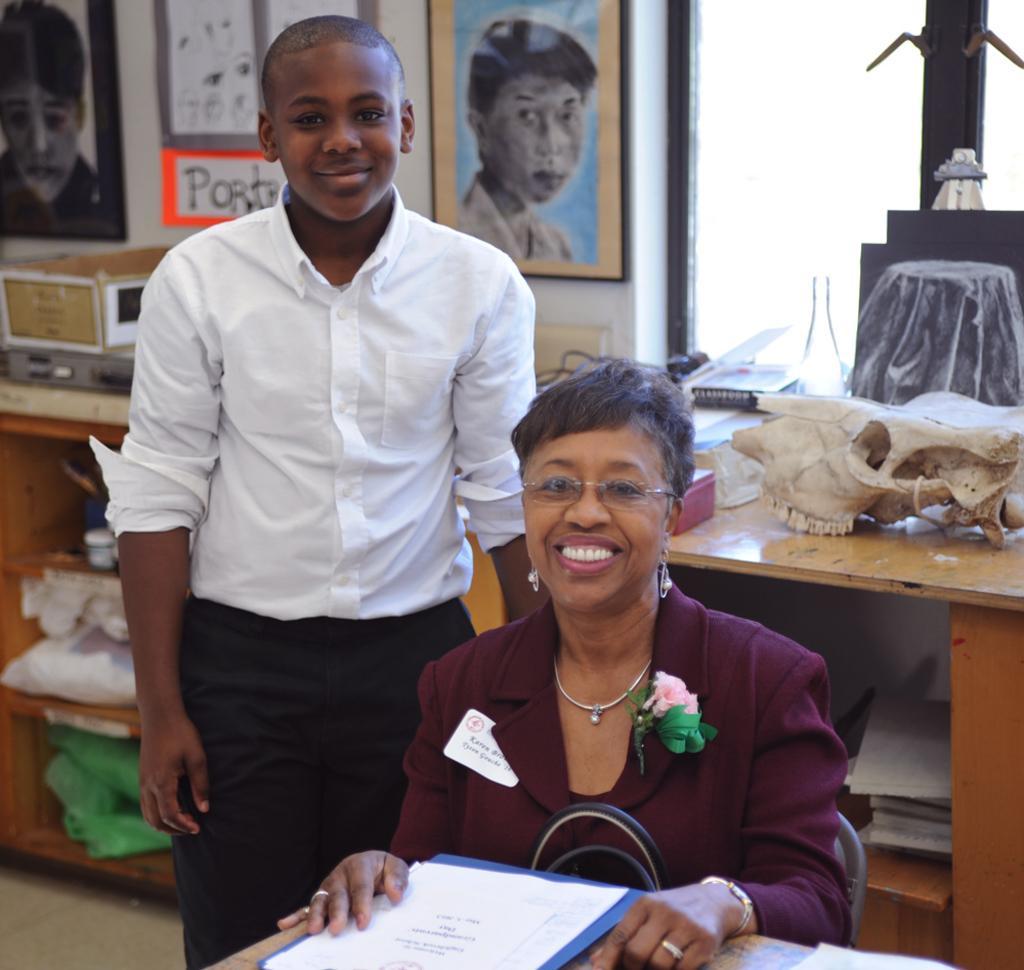How would you summarize this image in a sentence or two? In this picture we can see boy standing and here woman sitting and smiling and they are in front of the table and on table file, papers and in background we can see racks, poster, frames, window, bottle, book, some sculpture where women wore jacket, spectacle and flower to the jacket. 